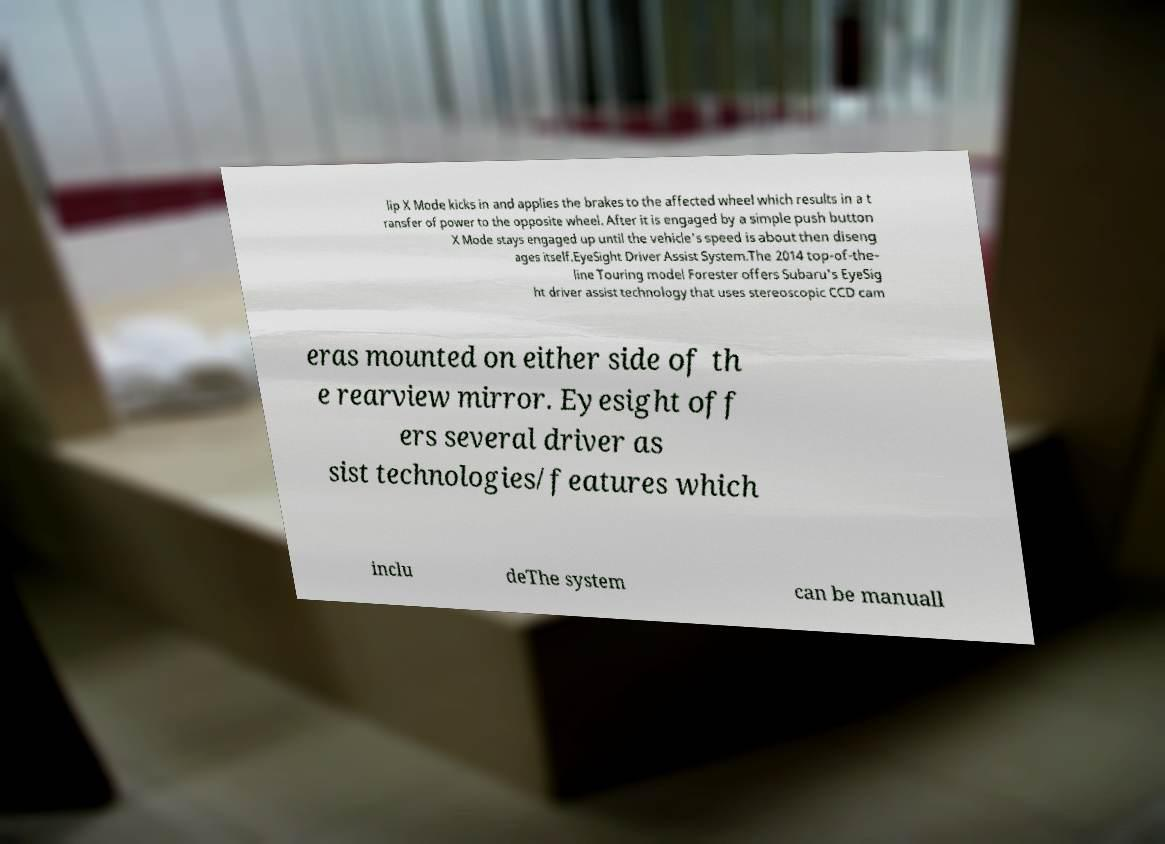What messages or text are displayed in this image? I need them in a readable, typed format. lip X Mode kicks in and applies the brakes to the affected wheel which results in a t ransfer of power to the opposite wheel. After it is engaged by a simple push button X Mode stays engaged up until the vehicle's speed is about then diseng ages itself.EyeSight Driver Assist System.The 2014 top-of-the- line Touring model Forester offers Subaru's EyeSig ht driver assist technology that uses stereoscopic CCD cam eras mounted on either side of th e rearview mirror. Eyesight off ers several driver as sist technologies/features which inclu deThe system can be manuall 